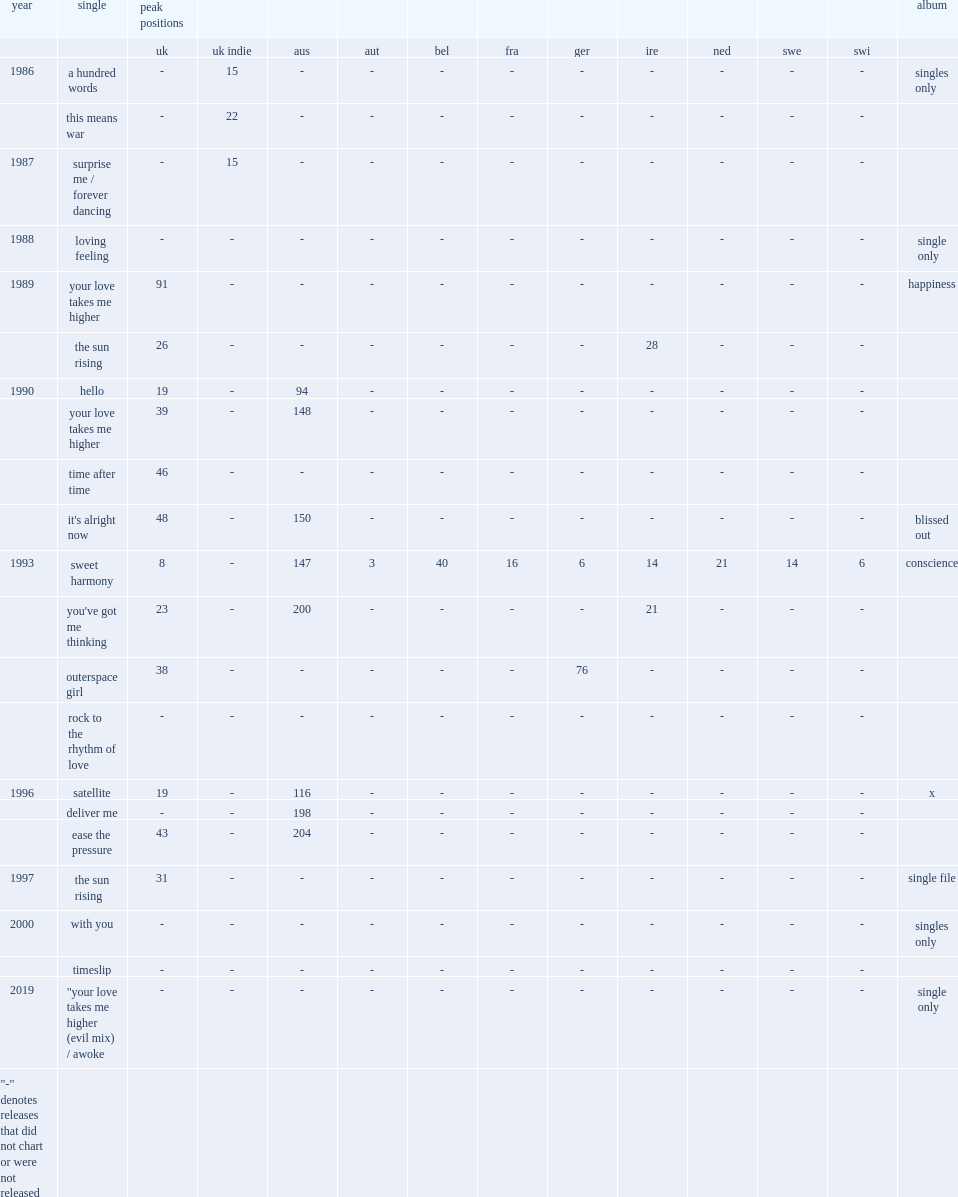In 1990, which album is released by the beloved and has the single "hello" ? Happiness. Can you parse all the data within this table? {'header': ['year', 'single', 'peak positions', '', '', '', '', '', '', '', '', '', '', 'album'], 'rows': [['', '', 'uk', 'uk indie', 'aus', 'aut', 'bel', 'fra', 'ger', 'ire', 'ned', 'swe', 'swi', ''], ['1986', 'a hundred words', '-', '15', '-', '-', '-', '-', '-', '-', '-', '-', '-', 'singles only'], ['', 'this means war', '-', '22', '-', '-', '-', '-', '-', '-', '-', '-', '-', ''], ['1987', 'surprise me / forever dancing', '-', '15', '-', '-', '-', '-', '-', '-', '-', '-', '-', ''], ['1988', 'loving feeling', '-', '-', '-', '-', '-', '-', '-', '-', '-', '-', '-', 'single only'], ['1989', 'your love takes me higher', '91', '-', '-', '-', '-', '-', '-', '-', '-', '-', '-', 'happiness'], ['', 'the sun rising', '26', '-', '-', '-', '-', '-', '-', '28', '-', '-', '-', ''], ['1990', 'hello', '19', '-', '94', '-', '-', '-', '-', '-', '-', '-', '-', ''], ['', 'your love takes me higher', '39', '-', '148', '-', '-', '-', '-', '-', '-', '-', '-', ''], ['', 'time after time', '46', '-', '-', '-', '-', '-', '-', '-', '-', '-', '-', ''], ['', "it's alright now", '48', '-', '150', '-', '-', '-', '-', '-', '-', '-', '-', 'blissed out'], ['1993', 'sweet harmony', '8', '-', '147', '3', '40', '16', '6', '14', '21', '14', '6', 'conscience'], ['', "you've got me thinking", '23', '-', '200', '-', '-', '-', '-', '21', '-', '-', '-', ''], ['', 'outerspace girl', '38', '-', '-', '-', '-', '-', '76', '-', '-', '-', '-', ''], ['', 'rock to the rhythm of love', '-', '-', '-', '-', '-', '-', '-', '-', '-', '-', '-', ''], ['1996', 'satellite', '19', '-', '116', '-', '-', '-', '-', '-', '-', '-', '-', 'x'], ['', 'deliver me', '-', '-', '198', '-', '-', '-', '-', '-', '-', '-', '-', ''], ['', 'ease the pressure', '43', '-', '204', '-', '-', '-', '-', '-', '-', '-', '-', ''], ['1997', 'the sun rising', '31', '-', '-', '-', '-', '-', '-', '-', '-', '-', '-', 'single file'], ['2000', 'with you', '-', '-', '-', '-', '-', '-', '-', '-', '-', '-', '-', 'singles only'], ['', 'timeslip', '-', '-', '-', '-', '-', '-', '-', '-', '-', '-', '-', ''], ['2019', '"your love takes me higher (evil mix) / awoke', '-', '-', '-', '-', '-', '-', '-', '-', '-', '-', '-', 'single only'], ['"-" denotes releases that did not chart or were not released', '', '', '', '', '', '', '', '', '', '', '', '', '']]} 